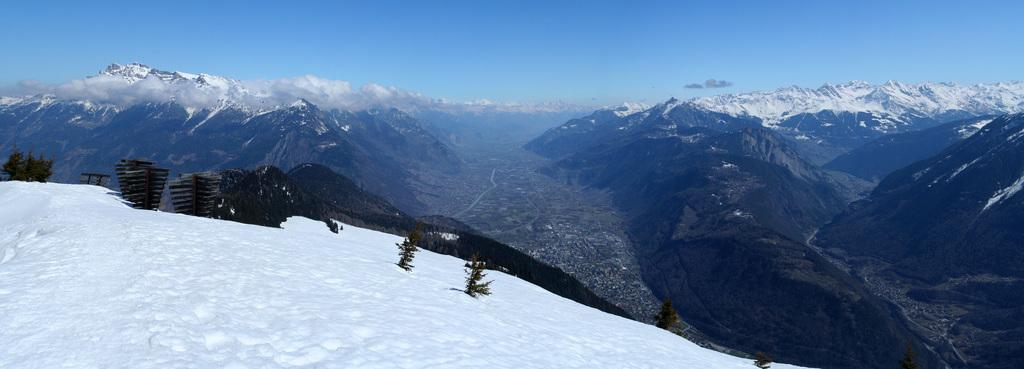What type of geographical features can be seen in the image? There are mountains and hills in the image. How are the mountains and hills depicted in the image? The mountains and hills are covered with snow. What else can be seen in the image besides the mountains and hills? The sky is visible in the image. How much wealth is visible in the image? There is no indication of wealth in the image; it features mountains, hills, and snow. What type of spark can be seen coming from the mountains in the image? There is no spark visible in the image; it only shows mountains, hills, and snow. 